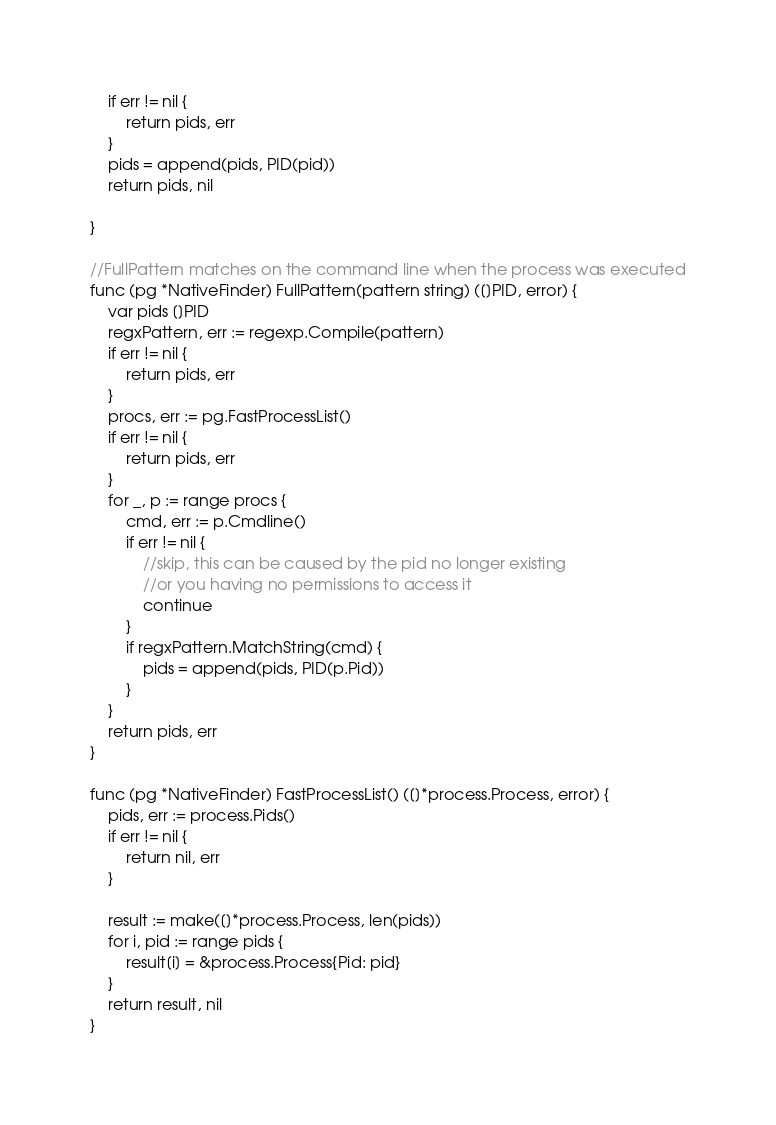<code> <loc_0><loc_0><loc_500><loc_500><_Go_>	if err != nil {
		return pids, err
	}
	pids = append(pids, PID(pid))
	return pids, nil

}

//FullPattern matches on the command line when the process was executed
func (pg *NativeFinder) FullPattern(pattern string) ([]PID, error) {
	var pids []PID
	regxPattern, err := regexp.Compile(pattern)
	if err != nil {
		return pids, err
	}
	procs, err := pg.FastProcessList()
	if err != nil {
		return pids, err
	}
	for _, p := range procs {
		cmd, err := p.Cmdline()
		if err != nil {
			//skip, this can be caused by the pid no longer existing
			//or you having no permissions to access it
			continue
		}
		if regxPattern.MatchString(cmd) {
			pids = append(pids, PID(p.Pid))
		}
	}
	return pids, err
}

func (pg *NativeFinder) FastProcessList() ([]*process.Process, error) {
	pids, err := process.Pids()
	if err != nil {
		return nil, err
	}

	result := make([]*process.Process, len(pids))
	for i, pid := range pids {
		result[i] = &process.Process{Pid: pid}
	}
	return result, nil
}
</code> 